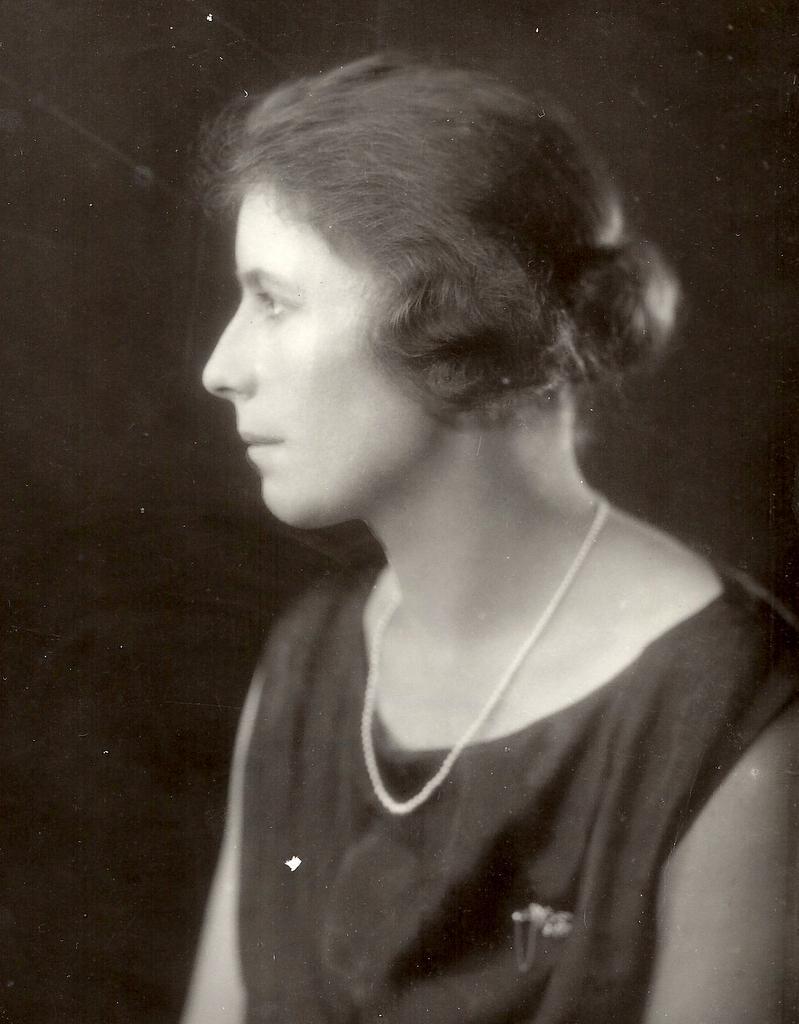In one or two sentences, can you explain what this image depicts? It looks like a black and white picture. We can see a woman and behind the woman there is a dark background. 